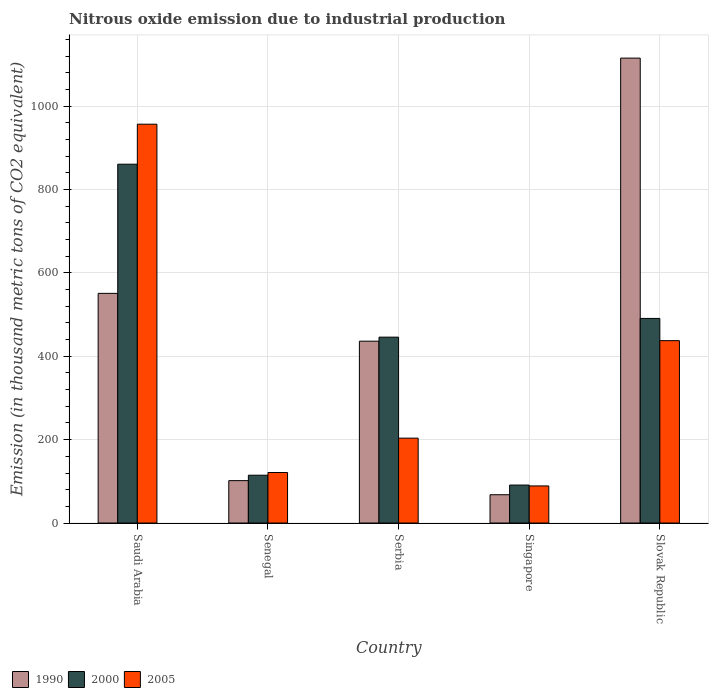How many different coloured bars are there?
Offer a terse response. 3. How many bars are there on the 5th tick from the left?
Your answer should be very brief. 3. What is the label of the 1st group of bars from the left?
Provide a short and direct response. Saudi Arabia. In how many cases, is the number of bars for a given country not equal to the number of legend labels?
Provide a succinct answer. 0. What is the amount of nitrous oxide emitted in 2005 in Slovak Republic?
Your answer should be very brief. 437.5. Across all countries, what is the maximum amount of nitrous oxide emitted in 2005?
Provide a succinct answer. 956.7. Across all countries, what is the minimum amount of nitrous oxide emitted in 2005?
Make the answer very short. 89. In which country was the amount of nitrous oxide emitted in 2000 maximum?
Your answer should be very brief. Saudi Arabia. In which country was the amount of nitrous oxide emitted in 1990 minimum?
Keep it short and to the point. Singapore. What is the total amount of nitrous oxide emitted in 2005 in the graph?
Keep it short and to the point. 1808. What is the difference between the amount of nitrous oxide emitted in 1990 in Senegal and that in Serbia?
Offer a very short reply. -334.5. What is the difference between the amount of nitrous oxide emitted in 1990 in Singapore and the amount of nitrous oxide emitted in 2005 in Saudi Arabia?
Your answer should be compact. -888.8. What is the average amount of nitrous oxide emitted in 1990 per country?
Ensure brevity in your answer.  454.38. What is the ratio of the amount of nitrous oxide emitted in 2000 in Senegal to that in Singapore?
Offer a very short reply. 1.26. Is the amount of nitrous oxide emitted in 2000 in Senegal less than that in Serbia?
Your answer should be very brief. Yes. What is the difference between the highest and the second highest amount of nitrous oxide emitted in 2005?
Offer a very short reply. -753.1. What is the difference between the highest and the lowest amount of nitrous oxide emitted in 1990?
Offer a very short reply. 1047.3. In how many countries, is the amount of nitrous oxide emitted in 2005 greater than the average amount of nitrous oxide emitted in 2005 taken over all countries?
Ensure brevity in your answer.  2. What does the 1st bar from the left in Senegal represents?
Give a very brief answer. 1990. What does the 3rd bar from the right in Singapore represents?
Your answer should be very brief. 1990. How many bars are there?
Offer a terse response. 15. What is the difference between two consecutive major ticks on the Y-axis?
Offer a very short reply. 200. How many legend labels are there?
Provide a succinct answer. 3. What is the title of the graph?
Your answer should be very brief. Nitrous oxide emission due to industrial production. Does "1969" appear as one of the legend labels in the graph?
Give a very brief answer. No. What is the label or title of the Y-axis?
Make the answer very short. Emission (in thousand metric tons of CO2 equivalent). What is the Emission (in thousand metric tons of CO2 equivalent) in 1990 in Saudi Arabia?
Ensure brevity in your answer.  550.9. What is the Emission (in thousand metric tons of CO2 equivalent) of 2000 in Saudi Arabia?
Provide a succinct answer. 860.7. What is the Emission (in thousand metric tons of CO2 equivalent) of 2005 in Saudi Arabia?
Your answer should be very brief. 956.7. What is the Emission (in thousand metric tons of CO2 equivalent) in 1990 in Senegal?
Provide a succinct answer. 101.7. What is the Emission (in thousand metric tons of CO2 equivalent) in 2000 in Senegal?
Keep it short and to the point. 114.7. What is the Emission (in thousand metric tons of CO2 equivalent) in 2005 in Senegal?
Offer a terse response. 121.2. What is the Emission (in thousand metric tons of CO2 equivalent) of 1990 in Serbia?
Offer a terse response. 436.2. What is the Emission (in thousand metric tons of CO2 equivalent) in 2000 in Serbia?
Give a very brief answer. 445.9. What is the Emission (in thousand metric tons of CO2 equivalent) of 2005 in Serbia?
Your answer should be compact. 203.6. What is the Emission (in thousand metric tons of CO2 equivalent) in 1990 in Singapore?
Offer a terse response. 67.9. What is the Emission (in thousand metric tons of CO2 equivalent) in 2000 in Singapore?
Provide a succinct answer. 91.1. What is the Emission (in thousand metric tons of CO2 equivalent) of 2005 in Singapore?
Provide a short and direct response. 89. What is the Emission (in thousand metric tons of CO2 equivalent) of 1990 in Slovak Republic?
Offer a very short reply. 1115.2. What is the Emission (in thousand metric tons of CO2 equivalent) in 2000 in Slovak Republic?
Offer a terse response. 490.8. What is the Emission (in thousand metric tons of CO2 equivalent) in 2005 in Slovak Republic?
Make the answer very short. 437.5. Across all countries, what is the maximum Emission (in thousand metric tons of CO2 equivalent) in 1990?
Give a very brief answer. 1115.2. Across all countries, what is the maximum Emission (in thousand metric tons of CO2 equivalent) in 2000?
Offer a very short reply. 860.7. Across all countries, what is the maximum Emission (in thousand metric tons of CO2 equivalent) of 2005?
Offer a terse response. 956.7. Across all countries, what is the minimum Emission (in thousand metric tons of CO2 equivalent) of 1990?
Your answer should be very brief. 67.9. Across all countries, what is the minimum Emission (in thousand metric tons of CO2 equivalent) of 2000?
Your answer should be compact. 91.1. Across all countries, what is the minimum Emission (in thousand metric tons of CO2 equivalent) of 2005?
Provide a succinct answer. 89. What is the total Emission (in thousand metric tons of CO2 equivalent) of 1990 in the graph?
Your answer should be very brief. 2271.9. What is the total Emission (in thousand metric tons of CO2 equivalent) of 2000 in the graph?
Provide a short and direct response. 2003.2. What is the total Emission (in thousand metric tons of CO2 equivalent) of 2005 in the graph?
Provide a succinct answer. 1808. What is the difference between the Emission (in thousand metric tons of CO2 equivalent) in 1990 in Saudi Arabia and that in Senegal?
Your response must be concise. 449.2. What is the difference between the Emission (in thousand metric tons of CO2 equivalent) in 2000 in Saudi Arabia and that in Senegal?
Give a very brief answer. 746. What is the difference between the Emission (in thousand metric tons of CO2 equivalent) of 2005 in Saudi Arabia and that in Senegal?
Your response must be concise. 835.5. What is the difference between the Emission (in thousand metric tons of CO2 equivalent) in 1990 in Saudi Arabia and that in Serbia?
Your answer should be compact. 114.7. What is the difference between the Emission (in thousand metric tons of CO2 equivalent) in 2000 in Saudi Arabia and that in Serbia?
Ensure brevity in your answer.  414.8. What is the difference between the Emission (in thousand metric tons of CO2 equivalent) of 2005 in Saudi Arabia and that in Serbia?
Offer a very short reply. 753.1. What is the difference between the Emission (in thousand metric tons of CO2 equivalent) in 1990 in Saudi Arabia and that in Singapore?
Give a very brief answer. 483. What is the difference between the Emission (in thousand metric tons of CO2 equivalent) in 2000 in Saudi Arabia and that in Singapore?
Ensure brevity in your answer.  769.6. What is the difference between the Emission (in thousand metric tons of CO2 equivalent) in 2005 in Saudi Arabia and that in Singapore?
Make the answer very short. 867.7. What is the difference between the Emission (in thousand metric tons of CO2 equivalent) in 1990 in Saudi Arabia and that in Slovak Republic?
Provide a short and direct response. -564.3. What is the difference between the Emission (in thousand metric tons of CO2 equivalent) of 2000 in Saudi Arabia and that in Slovak Republic?
Your response must be concise. 369.9. What is the difference between the Emission (in thousand metric tons of CO2 equivalent) of 2005 in Saudi Arabia and that in Slovak Republic?
Offer a terse response. 519.2. What is the difference between the Emission (in thousand metric tons of CO2 equivalent) in 1990 in Senegal and that in Serbia?
Give a very brief answer. -334.5. What is the difference between the Emission (in thousand metric tons of CO2 equivalent) of 2000 in Senegal and that in Serbia?
Your answer should be compact. -331.2. What is the difference between the Emission (in thousand metric tons of CO2 equivalent) in 2005 in Senegal and that in Serbia?
Your answer should be compact. -82.4. What is the difference between the Emission (in thousand metric tons of CO2 equivalent) of 1990 in Senegal and that in Singapore?
Make the answer very short. 33.8. What is the difference between the Emission (in thousand metric tons of CO2 equivalent) in 2000 in Senegal and that in Singapore?
Make the answer very short. 23.6. What is the difference between the Emission (in thousand metric tons of CO2 equivalent) of 2005 in Senegal and that in Singapore?
Ensure brevity in your answer.  32.2. What is the difference between the Emission (in thousand metric tons of CO2 equivalent) of 1990 in Senegal and that in Slovak Republic?
Ensure brevity in your answer.  -1013.5. What is the difference between the Emission (in thousand metric tons of CO2 equivalent) of 2000 in Senegal and that in Slovak Republic?
Keep it short and to the point. -376.1. What is the difference between the Emission (in thousand metric tons of CO2 equivalent) of 2005 in Senegal and that in Slovak Republic?
Your response must be concise. -316.3. What is the difference between the Emission (in thousand metric tons of CO2 equivalent) of 1990 in Serbia and that in Singapore?
Make the answer very short. 368.3. What is the difference between the Emission (in thousand metric tons of CO2 equivalent) of 2000 in Serbia and that in Singapore?
Ensure brevity in your answer.  354.8. What is the difference between the Emission (in thousand metric tons of CO2 equivalent) of 2005 in Serbia and that in Singapore?
Make the answer very short. 114.6. What is the difference between the Emission (in thousand metric tons of CO2 equivalent) of 1990 in Serbia and that in Slovak Republic?
Provide a succinct answer. -679. What is the difference between the Emission (in thousand metric tons of CO2 equivalent) in 2000 in Serbia and that in Slovak Republic?
Provide a short and direct response. -44.9. What is the difference between the Emission (in thousand metric tons of CO2 equivalent) of 2005 in Serbia and that in Slovak Republic?
Ensure brevity in your answer.  -233.9. What is the difference between the Emission (in thousand metric tons of CO2 equivalent) in 1990 in Singapore and that in Slovak Republic?
Offer a terse response. -1047.3. What is the difference between the Emission (in thousand metric tons of CO2 equivalent) of 2000 in Singapore and that in Slovak Republic?
Your answer should be very brief. -399.7. What is the difference between the Emission (in thousand metric tons of CO2 equivalent) in 2005 in Singapore and that in Slovak Republic?
Keep it short and to the point. -348.5. What is the difference between the Emission (in thousand metric tons of CO2 equivalent) of 1990 in Saudi Arabia and the Emission (in thousand metric tons of CO2 equivalent) of 2000 in Senegal?
Your answer should be very brief. 436.2. What is the difference between the Emission (in thousand metric tons of CO2 equivalent) in 1990 in Saudi Arabia and the Emission (in thousand metric tons of CO2 equivalent) in 2005 in Senegal?
Ensure brevity in your answer.  429.7. What is the difference between the Emission (in thousand metric tons of CO2 equivalent) of 2000 in Saudi Arabia and the Emission (in thousand metric tons of CO2 equivalent) of 2005 in Senegal?
Your answer should be very brief. 739.5. What is the difference between the Emission (in thousand metric tons of CO2 equivalent) of 1990 in Saudi Arabia and the Emission (in thousand metric tons of CO2 equivalent) of 2000 in Serbia?
Make the answer very short. 105. What is the difference between the Emission (in thousand metric tons of CO2 equivalent) of 1990 in Saudi Arabia and the Emission (in thousand metric tons of CO2 equivalent) of 2005 in Serbia?
Your answer should be compact. 347.3. What is the difference between the Emission (in thousand metric tons of CO2 equivalent) in 2000 in Saudi Arabia and the Emission (in thousand metric tons of CO2 equivalent) in 2005 in Serbia?
Provide a short and direct response. 657.1. What is the difference between the Emission (in thousand metric tons of CO2 equivalent) in 1990 in Saudi Arabia and the Emission (in thousand metric tons of CO2 equivalent) in 2000 in Singapore?
Your answer should be very brief. 459.8. What is the difference between the Emission (in thousand metric tons of CO2 equivalent) in 1990 in Saudi Arabia and the Emission (in thousand metric tons of CO2 equivalent) in 2005 in Singapore?
Offer a very short reply. 461.9. What is the difference between the Emission (in thousand metric tons of CO2 equivalent) of 2000 in Saudi Arabia and the Emission (in thousand metric tons of CO2 equivalent) of 2005 in Singapore?
Your response must be concise. 771.7. What is the difference between the Emission (in thousand metric tons of CO2 equivalent) of 1990 in Saudi Arabia and the Emission (in thousand metric tons of CO2 equivalent) of 2000 in Slovak Republic?
Your answer should be compact. 60.1. What is the difference between the Emission (in thousand metric tons of CO2 equivalent) in 1990 in Saudi Arabia and the Emission (in thousand metric tons of CO2 equivalent) in 2005 in Slovak Republic?
Provide a succinct answer. 113.4. What is the difference between the Emission (in thousand metric tons of CO2 equivalent) of 2000 in Saudi Arabia and the Emission (in thousand metric tons of CO2 equivalent) of 2005 in Slovak Republic?
Make the answer very short. 423.2. What is the difference between the Emission (in thousand metric tons of CO2 equivalent) in 1990 in Senegal and the Emission (in thousand metric tons of CO2 equivalent) in 2000 in Serbia?
Your answer should be very brief. -344.2. What is the difference between the Emission (in thousand metric tons of CO2 equivalent) of 1990 in Senegal and the Emission (in thousand metric tons of CO2 equivalent) of 2005 in Serbia?
Provide a succinct answer. -101.9. What is the difference between the Emission (in thousand metric tons of CO2 equivalent) of 2000 in Senegal and the Emission (in thousand metric tons of CO2 equivalent) of 2005 in Serbia?
Make the answer very short. -88.9. What is the difference between the Emission (in thousand metric tons of CO2 equivalent) in 1990 in Senegal and the Emission (in thousand metric tons of CO2 equivalent) in 2005 in Singapore?
Give a very brief answer. 12.7. What is the difference between the Emission (in thousand metric tons of CO2 equivalent) in 2000 in Senegal and the Emission (in thousand metric tons of CO2 equivalent) in 2005 in Singapore?
Offer a very short reply. 25.7. What is the difference between the Emission (in thousand metric tons of CO2 equivalent) in 1990 in Senegal and the Emission (in thousand metric tons of CO2 equivalent) in 2000 in Slovak Republic?
Make the answer very short. -389.1. What is the difference between the Emission (in thousand metric tons of CO2 equivalent) in 1990 in Senegal and the Emission (in thousand metric tons of CO2 equivalent) in 2005 in Slovak Republic?
Provide a succinct answer. -335.8. What is the difference between the Emission (in thousand metric tons of CO2 equivalent) in 2000 in Senegal and the Emission (in thousand metric tons of CO2 equivalent) in 2005 in Slovak Republic?
Your answer should be very brief. -322.8. What is the difference between the Emission (in thousand metric tons of CO2 equivalent) of 1990 in Serbia and the Emission (in thousand metric tons of CO2 equivalent) of 2000 in Singapore?
Provide a short and direct response. 345.1. What is the difference between the Emission (in thousand metric tons of CO2 equivalent) in 1990 in Serbia and the Emission (in thousand metric tons of CO2 equivalent) in 2005 in Singapore?
Offer a terse response. 347.2. What is the difference between the Emission (in thousand metric tons of CO2 equivalent) in 2000 in Serbia and the Emission (in thousand metric tons of CO2 equivalent) in 2005 in Singapore?
Provide a short and direct response. 356.9. What is the difference between the Emission (in thousand metric tons of CO2 equivalent) of 1990 in Serbia and the Emission (in thousand metric tons of CO2 equivalent) of 2000 in Slovak Republic?
Make the answer very short. -54.6. What is the difference between the Emission (in thousand metric tons of CO2 equivalent) of 2000 in Serbia and the Emission (in thousand metric tons of CO2 equivalent) of 2005 in Slovak Republic?
Make the answer very short. 8.4. What is the difference between the Emission (in thousand metric tons of CO2 equivalent) of 1990 in Singapore and the Emission (in thousand metric tons of CO2 equivalent) of 2000 in Slovak Republic?
Give a very brief answer. -422.9. What is the difference between the Emission (in thousand metric tons of CO2 equivalent) of 1990 in Singapore and the Emission (in thousand metric tons of CO2 equivalent) of 2005 in Slovak Republic?
Your response must be concise. -369.6. What is the difference between the Emission (in thousand metric tons of CO2 equivalent) in 2000 in Singapore and the Emission (in thousand metric tons of CO2 equivalent) in 2005 in Slovak Republic?
Give a very brief answer. -346.4. What is the average Emission (in thousand metric tons of CO2 equivalent) of 1990 per country?
Give a very brief answer. 454.38. What is the average Emission (in thousand metric tons of CO2 equivalent) of 2000 per country?
Give a very brief answer. 400.64. What is the average Emission (in thousand metric tons of CO2 equivalent) of 2005 per country?
Make the answer very short. 361.6. What is the difference between the Emission (in thousand metric tons of CO2 equivalent) of 1990 and Emission (in thousand metric tons of CO2 equivalent) of 2000 in Saudi Arabia?
Provide a succinct answer. -309.8. What is the difference between the Emission (in thousand metric tons of CO2 equivalent) of 1990 and Emission (in thousand metric tons of CO2 equivalent) of 2005 in Saudi Arabia?
Give a very brief answer. -405.8. What is the difference between the Emission (in thousand metric tons of CO2 equivalent) of 2000 and Emission (in thousand metric tons of CO2 equivalent) of 2005 in Saudi Arabia?
Your response must be concise. -96. What is the difference between the Emission (in thousand metric tons of CO2 equivalent) of 1990 and Emission (in thousand metric tons of CO2 equivalent) of 2000 in Senegal?
Offer a very short reply. -13. What is the difference between the Emission (in thousand metric tons of CO2 equivalent) of 1990 and Emission (in thousand metric tons of CO2 equivalent) of 2005 in Senegal?
Your answer should be very brief. -19.5. What is the difference between the Emission (in thousand metric tons of CO2 equivalent) of 1990 and Emission (in thousand metric tons of CO2 equivalent) of 2000 in Serbia?
Offer a very short reply. -9.7. What is the difference between the Emission (in thousand metric tons of CO2 equivalent) in 1990 and Emission (in thousand metric tons of CO2 equivalent) in 2005 in Serbia?
Provide a short and direct response. 232.6. What is the difference between the Emission (in thousand metric tons of CO2 equivalent) of 2000 and Emission (in thousand metric tons of CO2 equivalent) of 2005 in Serbia?
Your answer should be very brief. 242.3. What is the difference between the Emission (in thousand metric tons of CO2 equivalent) in 1990 and Emission (in thousand metric tons of CO2 equivalent) in 2000 in Singapore?
Provide a succinct answer. -23.2. What is the difference between the Emission (in thousand metric tons of CO2 equivalent) in 1990 and Emission (in thousand metric tons of CO2 equivalent) in 2005 in Singapore?
Your answer should be very brief. -21.1. What is the difference between the Emission (in thousand metric tons of CO2 equivalent) in 1990 and Emission (in thousand metric tons of CO2 equivalent) in 2000 in Slovak Republic?
Give a very brief answer. 624.4. What is the difference between the Emission (in thousand metric tons of CO2 equivalent) in 1990 and Emission (in thousand metric tons of CO2 equivalent) in 2005 in Slovak Republic?
Provide a short and direct response. 677.7. What is the difference between the Emission (in thousand metric tons of CO2 equivalent) of 2000 and Emission (in thousand metric tons of CO2 equivalent) of 2005 in Slovak Republic?
Provide a succinct answer. 53.3. What is the ratio of the Emission (in thousand metric tons of CO2 equivalent) in 1990 in Saudi Arabia to that in Senegal?
Provide a succinct answer. 5.42. What is the ratio of the Emission (in thousand metric tons of CO2 equivalent) of 2000 in Saudi Arabia to that in Senegal?
Your answer should be very brief. 7.5. What is the ratio of the Emission (in thousand metric tons of CO2 equivalent) of 2005 in Saudi Arabia to that in Senegal?
Provide a succinct answer. 7.89. What is the ratio of the Emission (in thousand metric tons of CO2 equivalent) of 1990 in Saudi Arabia to that in Serbia?
Provide a short and direct response. 1.26. What is the ratio of the Emission (in thousand metric tons of CO2 equivalent) in 2000 in Saudi Arabia to that in Serbia?
Offer a very short reply. 1.93. What is the ratio of the Emission (in thousand metric tons of CO2 equivalent) of 2005 in Saudi Arabia to that in Serbia?
Provide a short and direct response. 4.7. What is the ratio of the Emission (in thousand metric tons of CO2 equivalent) of 1990 in Saudi Arabia to that in Singapore?
Offer a very short reply. 8.11. What is the ratio of the Emission (in thousand metric tons of CO2 equivalent) of 2000 in Saudi Arabia to that in Singapore?
Make the answer very short. 9.45. What is the ratio of the Emission (in thousand metric tons of CO2 equivalent) of 2005 in Saudi Arabia to that in Singapore?
Offer a very short reply. 10.75. What is the ratio of the Emission (in thousand metric tons of CO2 equivalent) in 1990 in Saudi Arabia to that in Slovak Republic?
Provide a short and direct response. 0.49. What is the ratio of the Emission (in thousand metric tons of CO2 equivalent) of 2000 in Saudi Arabia to that in Slovak Republic?
Your answer should be compact. 1.75. What is the ratio of the Emission (in thousand metric tons of CO2 equivalent) of 2005 in Saudi Arabia to that in Slovak Republic?
Provide a short and direct response. 2.19. What is the ratio of the Emission (in thousand metric tons of CO2 equivalent) in 1990 in Senegal to that in Serbia?
Your answer should be compact. 0.23. What is the ratio of the Emission (in thousand metric tons of CO2 equivalent) of 2000 in Senegal to that in Serbia?
Offer a terse response. 0.26. What is the ratio of the Emission (in thousand metric tons of CO2 equivalent) of 2005 in Senegal to that in Serbia?
Offer a very short reply. 0.6. What is the ratio of the Emission (in thousand metric tons of CO2 equivalent) in 1990 in Senegal to that in Singapore?
Keep it short and to the point. 1.5. What is the ratio of the Emission (in thousand metric tons of CO2 equivalent) of 2000 in Senegal to that in Singapore?
Ensure brevity in your answer.  1.26. What is the ratio of the Emission (in thousand metric tons of CO2 equivalent) of 2005 in Senegal to that in Singapore?
Ensure brevity in your answer.  1.36. What is the ratio of the Emission (in thousand metric tons of CO2 equivalent) of 1990 in Senegal to that in Slovak Republic?
Ensure brevity in your answer.  0.09. What is the ratio of the Emission (in thousand metric tons of CO2 equivalent) in 2000 in Senegal to that in Slovak Republic?
Ensure brevity in your answer.  0.23. What is the ratio of the Emission (in thousand metric tons of CO2 equivalent) in 2005 in Senegal to that in Slovak Republic?
Offer a very short reply. 0.28. What is the ratio of the Emission (in thousand metric tons of CO2 equivalent) of 1990 in Serbia to that in Singapore?
Offer a very short reply. 6.42. What is the ratio of the Emission (in thousand metric tons of CO2 equivalent) of 2000 in Serbia to that in Singapore?
Your response must be concise. 4.89. What is the ratio of the Emission (in thousand metric tons of CO2 equivalent) of 2005 in Serbia to that in Singapore?
Your answer should be very brief. 2.29. What is the ratio of the Emission (in thousand metric tons of CO2 equivalent) of 1990 in Serbia to that in Slovak Republic?
Offer a very short reply. 0.39. What is the ratio of the Emission (in thousand metric tons of CO2 equivalent) of 2000 in Serbia to that in Slovak Republic?
Make the answer very short. 0.91. What is the ratio of the Emission (in thousand metric tons of CO2 equivalent) in 2005 in Serbia to that in Slovak Republic?
Give a very brief answer. 0.47. What is the ratio of the Emission (in thousand metric tons of CO2 equivalent) of 1990 in Singapore to that in Slovak Republic?
Ensure brevity in your answer.  0.06. What is the ratio of the Emission (in thousand metric tons of CO2 equivalent) in 2000 in Singapore to that in Slovak Republic?
Your response must be concise. 0.19. What is the ratio of the Emission (in thousand metric tons of CO2 equivalent) in 2005 in Singapore to that in Slovak Republic?
Offer a terse response. 0.2. What is the difference between the highest and the second highest Emission (in thousand metric tons of CO2 equivalent) in 1990?
Your answer should be very brief. 564.3. What is the difference between the highest and the second highest Emission (in thousand metric tons of CO2 equivalent) of 2000?
Provide a short and direct response. 369.9. What is the difference between the highest and the second highest Emission (in thousand metric tons of CO2 equivalent) in 2005?
Keep it short and to the point. 519.2. What is the difference between the highest and the lowest Emission (in thousand metric tons of CO2 equivalent) in 1990?
Ensure brevity in your answer.  1047.3. What is the difference between the highest and the lowest Emission (in thousand metric tons of CO2 equivalent) in 2000?
Provide a short and direct response. 769.6. What is the difference between the highest and the lowest Emission (in thousand metric tons of CO2 equivalent) in 2005?
Offer a terse response. 867.7. 